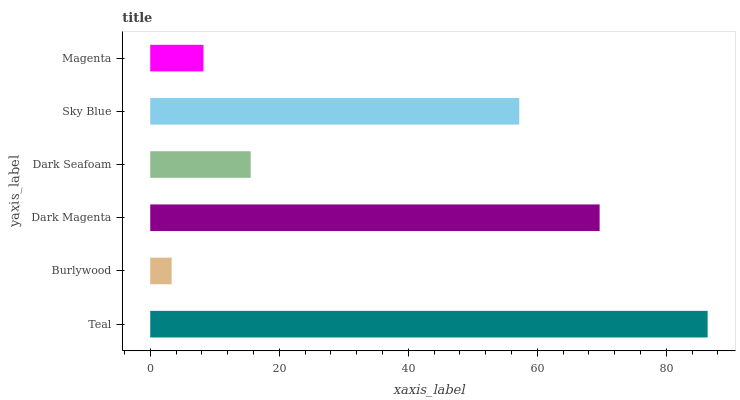Is Burlywood the minimum?
Answer yes or no. Yes. Is Teal the maximum?
Answer yes or no. Yes. Is Dark Magenta the minimum?
Answer yes or no. No. Is Dark Magenta the maximum?
Answer yes or no. No. Is Dark Magenta greater than Burlywood?
Answer yes or no. Yes. Is Burlywood less than Dark Magenta?
Answer yes or no. Yes. Is Burlywood greater than Dark Magenta?
Answer yes or no. No. Is Dark Magenta less than Burlywood?
Answer yes or no. No. Is Sky Blue the high median?
Answer yes or no. Yes. Is Dark Seafoam the low median?
Answer yes or no. Yes. Is Dark Magenta the high median?
Answer yes or no. No. Is Magenta the low median?
Answer yes or no. No. 